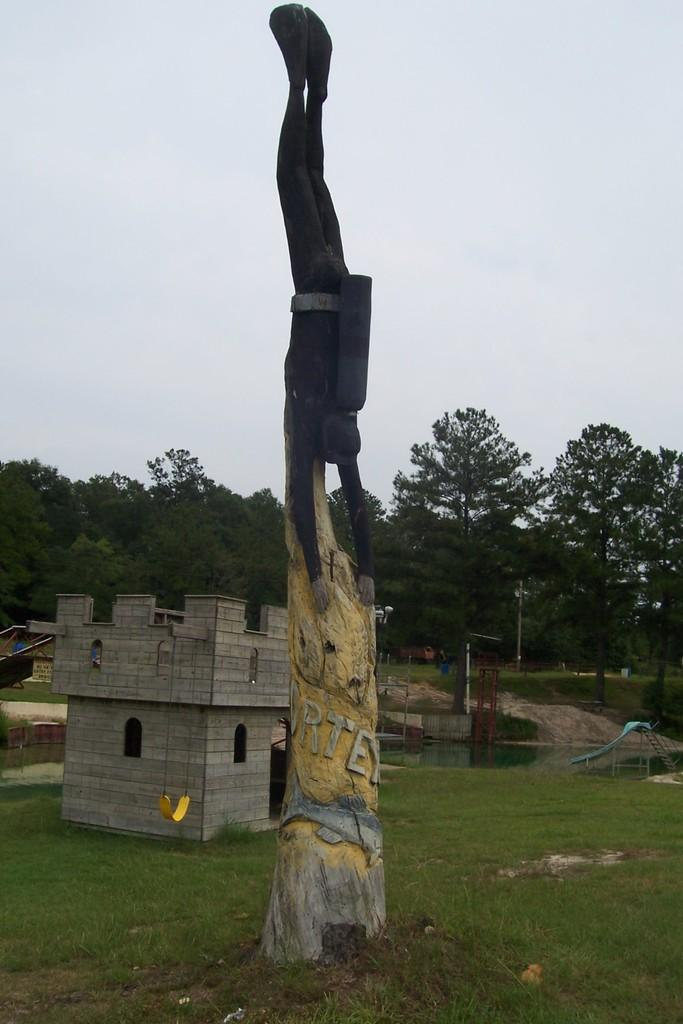What is located on the ground in the image? There is a sculpture on the ground in the image. What can be seen in the background of the image? There is a shed, trees, and some unspecified objects in the background of the image. What is visible in the sky in the image? The sky is visible in the background of the image. What type of knot is used to secure the sculpture to the ground in the image? There is no knot visible in the image, as the sculpture is not tied to the ground. 